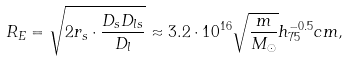Convert formula to latex. <formula><loc_0><loc_0><loc_500><loc_500>R _ { E } = \sqrt { 2 r _ { s } \cdot \frac { D _ { s } D _ { l s } } { D _ { l } } } \approx 3 . 2 \cdot 1 0 ^ { 1 6 } \sqrt { \frac { m } { M _ { \odot } } } h _ { 7 5 } ^ { - 0 . 5 } c m ,</formula> 